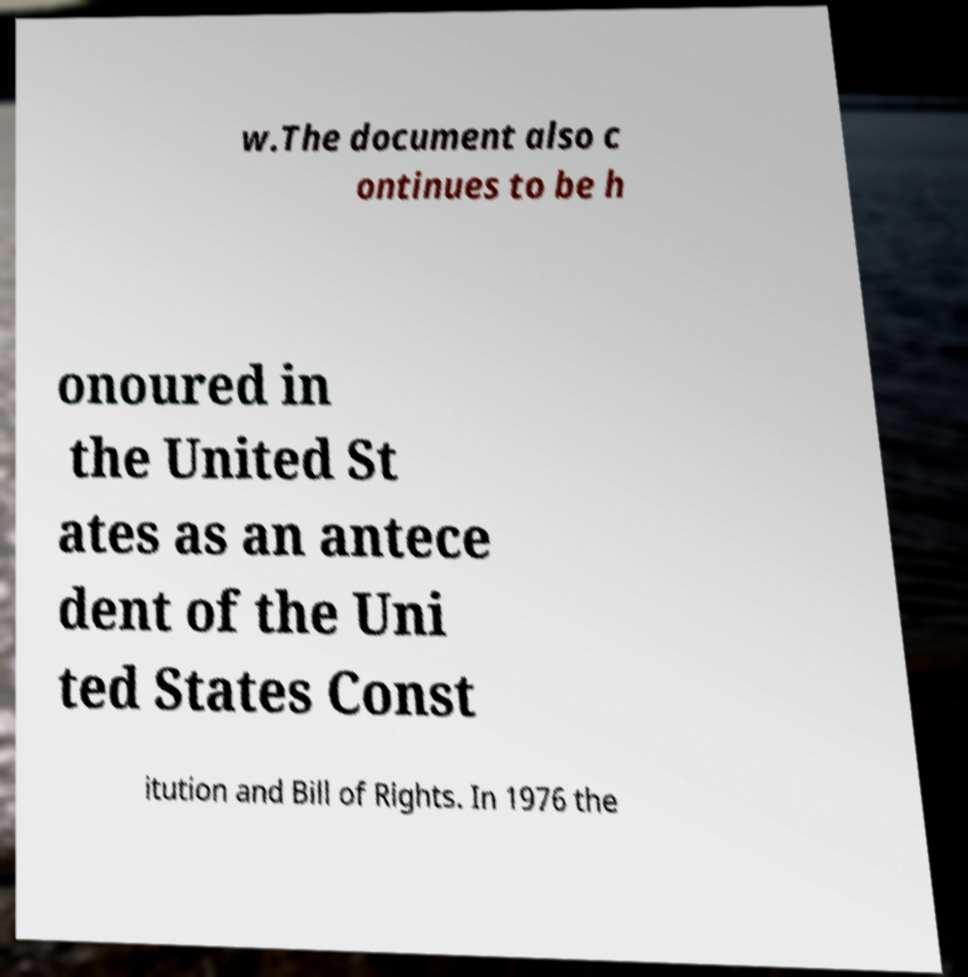Could you assist in decoding the text presented in this image and type it out clearly? w.The document also c ontinues to be h onoured in the United St ates as an antece dent of the Uni ted States Const itution and Bill of Rights. In 1976 the 